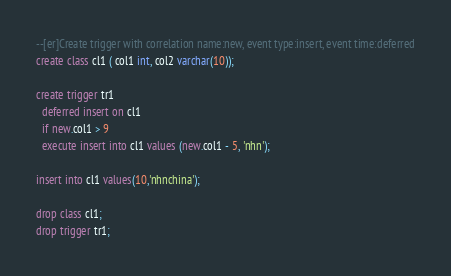<code> <loc_0><loc_0><loc_500><loc_500><_SQL_>--[er]Create trigger with correlation name:new, event type:insert, event time:deferred
create class cl1 ( col1 int, col2 varchar(10));

create trigger tr1
  deferred insert on cl1
  if new.col1 > 9
  execute insert into cl1 values (new.col1 - 5, 'nhn');
  
insert into cl1 values(10,'nhnchina');

drop class cl1;
drop trigger tr1;</code> 